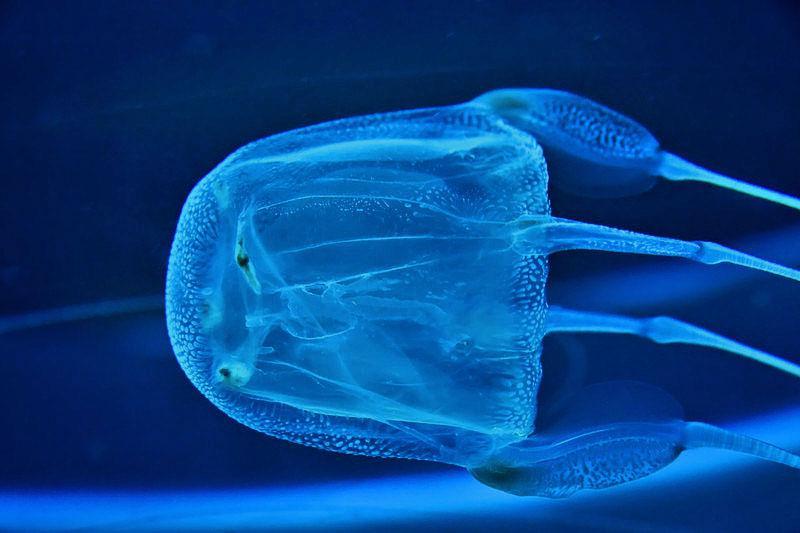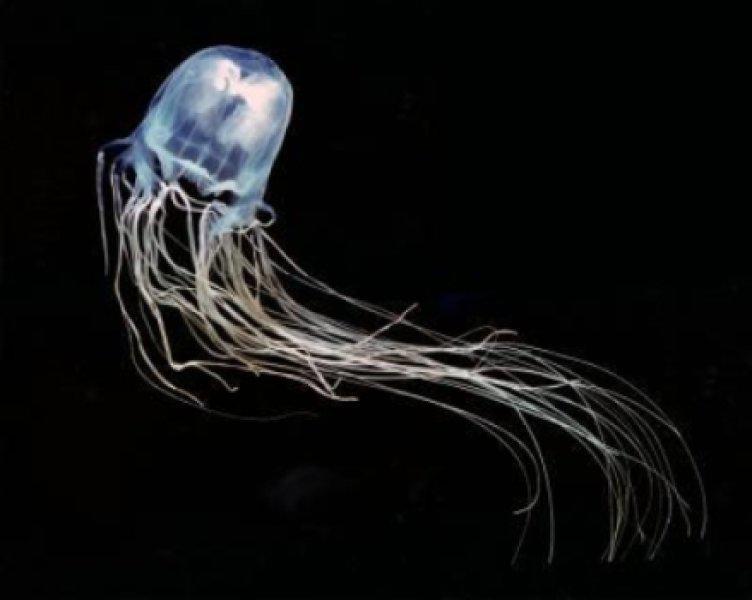The first image is the image on the left, the second image is the image on the right. Given the left and right images, does the statement "The jellyfish is swimming to the left in the image on the left" hold true? Answer yes or no. Yes. 